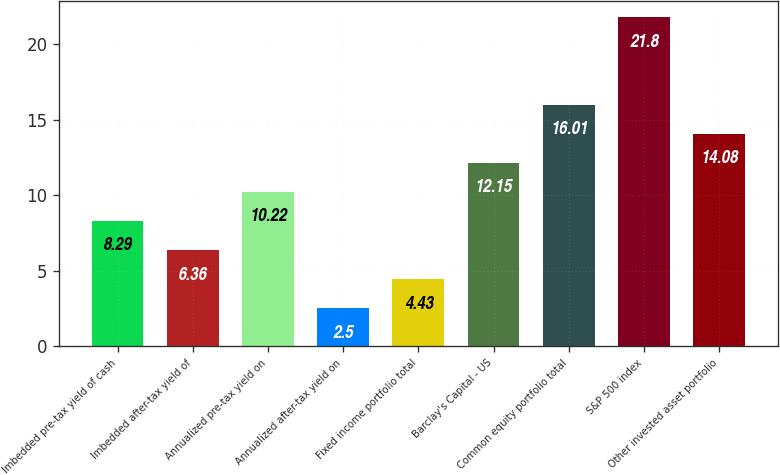Convert chart to OTSL. <chart><loc_0><loc_0><loc_500><loc_500><bar_chart><fcel>Imbedded pre-tax yield of cash<fcel>Imbedded after-tax yield of<fcel>Annualized pre-tax yield on<fcel>Annualized after-tax yield on<fcel>Fixed income portfolio total<fcel>Barclay's Capital - US<fcel>Common equity portfolio total<fcel>S&P 500 index<fcel>Other invested asset portfolio<nl><fcel>8.29<fcel>6.36<fcel>10.22<fcel>2.5<fcel>4.43<fcel>12.15<fcel>16.01<fcel>21.8<fcel>14.08<nl></chart> 